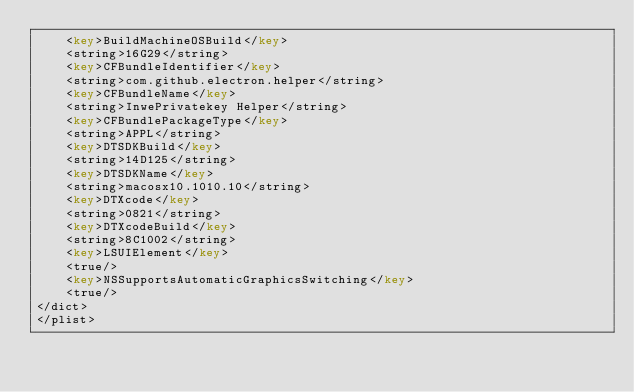Convert code to text. <code><loc_0><loc_0><loc_500><loc_500><_XML_>	<key>BuildMachineOSBuild</key>
	<string>16G29</string>
	<key>CFBundleIdentifier</key>
	<string>com.github.electron.helper</string>
	<key>CFBundleName</key>
	<string>InwePrivatekey Helper</string>
	<key>CFBundlePackageType</key>
	<string>APPL</string>
	<key>DTSDKBuild</key>
	<string>14D125</string>
	<key>DTSDKName</key>
	<string>macosx10.1010.10</string>
	<key>DTXcode</key>
	<string>0821</string>
	<key>DTXcodeBuild</key>
	<string>8C1002</string>
	<key>LSUIElement</key>
	<true/>
	<key>NSSupportsAutomaticGraphicsSwitching</key>
	<true/>
</dict>
</plist>
</code> 